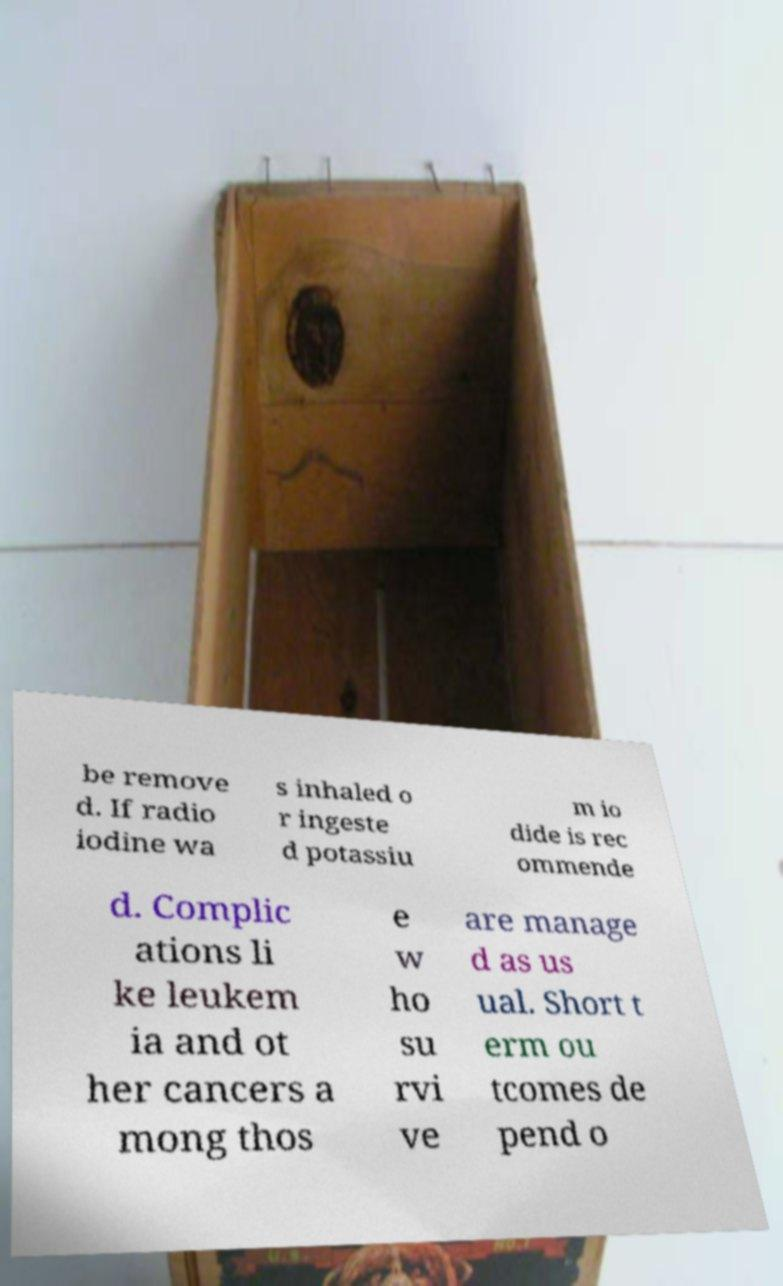Please identify and transcribe the text found in this image. be remove d. If radio iodine wa s inhaled o r ingeste d potassiu m io dide is rec ommende d. Complic ations li ke leukem ia and ot her cancers a mong thos e w ho su rvi ve are manage d as us ual. Short t erm ou tcomes de pend o 